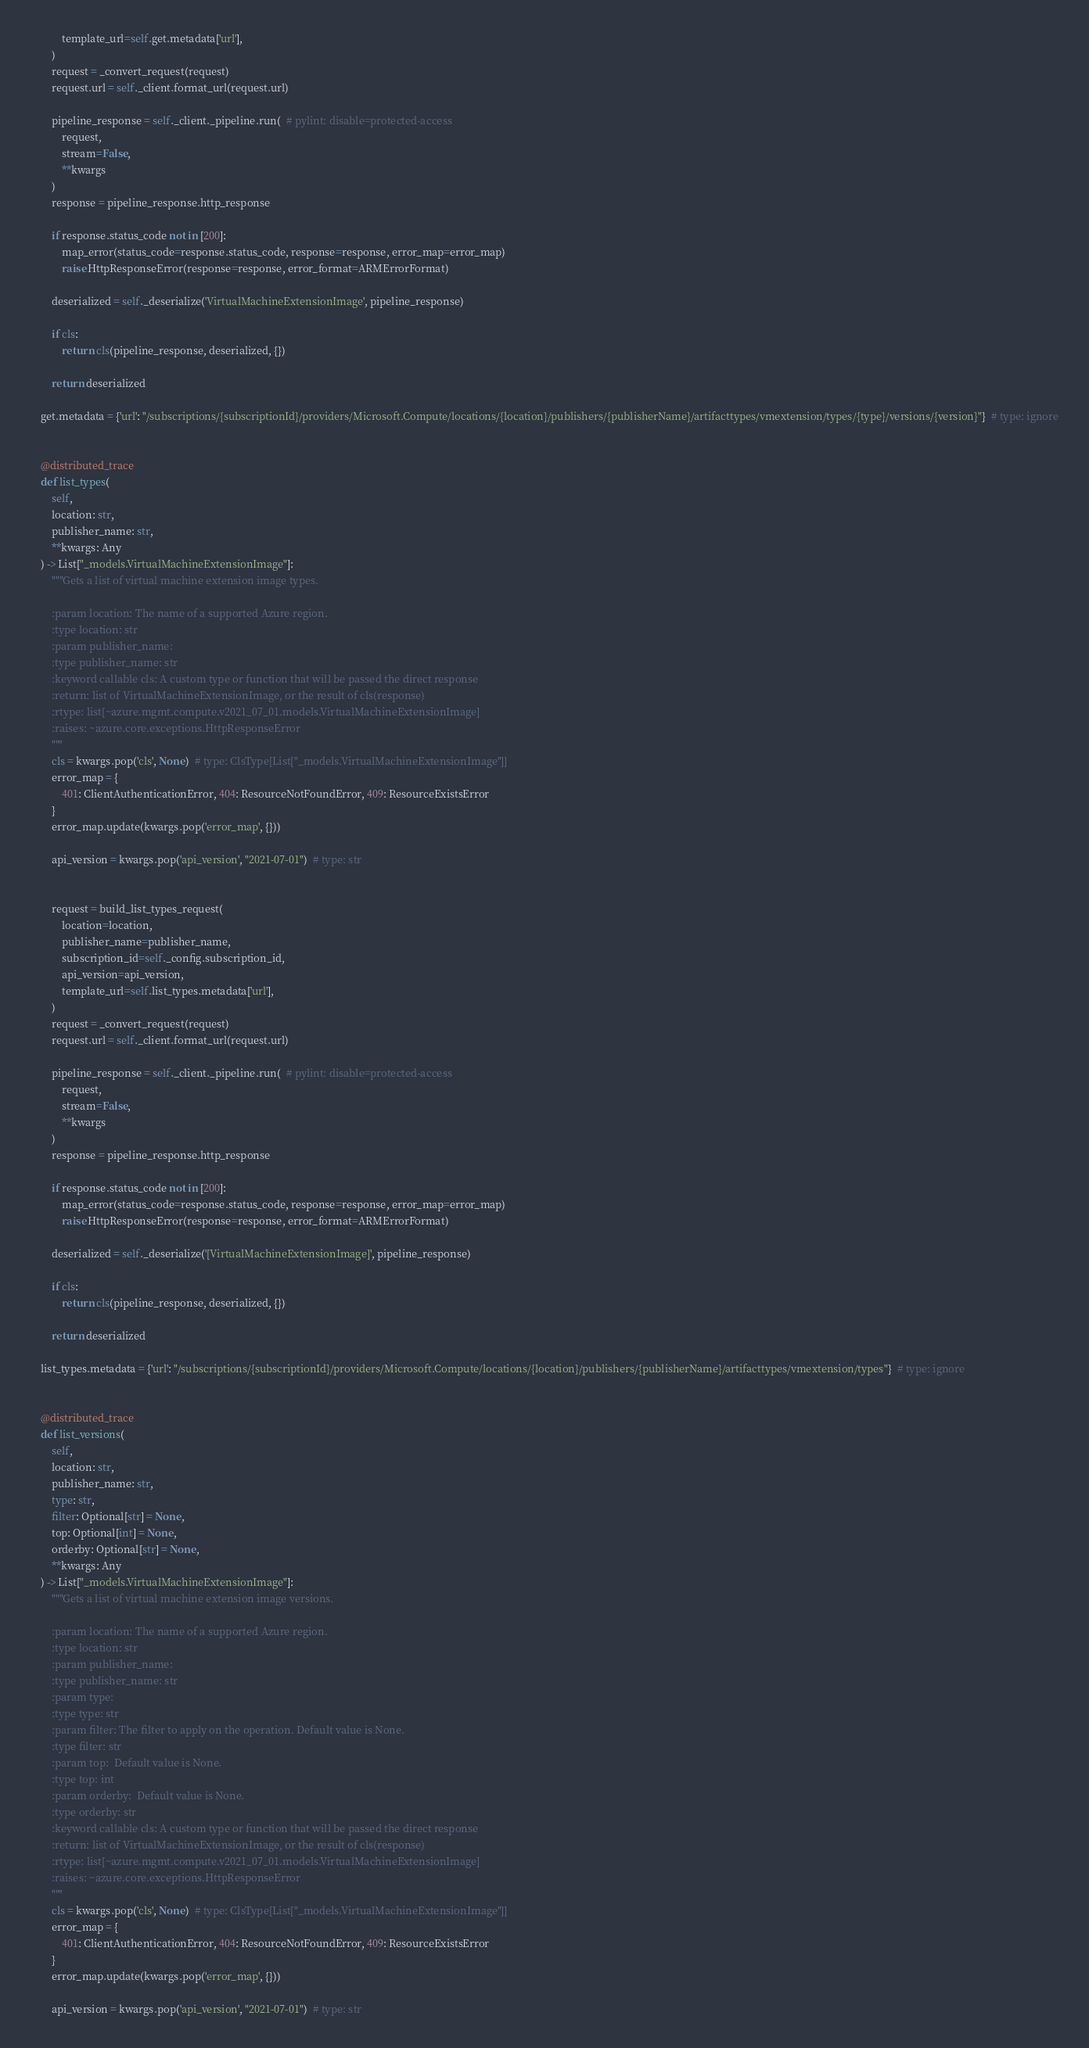<code> <loc_0><loc_0><loc_500><loc_500><_Python_>            template_url=self.get.metadata['url'],
        )
        request = _convert_request(request)
        request.url = self._client.format_url(request.url)

        pipeline_response = self._client._pipeline.run(  # pylint: disable=protected-access
            request,
            stream=False,
            **kwargs
        )
        response = pipeline_response.http_response

        if response.status_code not in [200]:
            map_error(status_code=response.status_code, response=response, error_map=error_map)
            raise HttpResponseError(response=response, error_format=ARMErrorFormat)

        deserialized = self._deserialize('VirtualMachineExtensionImage', pipeline_response)

        if cls:
            return cls(pipeline_response, deserialized, {})

        return deserialized

    get.metadata = {'url': "/subscriptions/{subscriptionId}/providers/Microsoft.Compute/locations/{location}/publishers/{publisherName}/artifacttypes/vmextension/types/{type}/versions/{version}"}  # type: ignore


    @distributed_trace
    def list_types(
        self,
        location: str,
        publisher_name: str,
        **kwargs: Any
    ) -> List["_models.VirtualMachineExtensionImage"]:
        """Gets a list of virtual machine extension image types.

        :param location: The name of a supported Azure region.
        :type location: str
        :param publisher_name:
        :type publisher_name: str
        :keyword callable cls: A custom type or function that will be passed the direct response
        :return: list of VirtualMachineExtensionImage, or the result of cls(response)
        :rtype: list[~azure.mgmt.compute.v2021_07_01.models.VirtualMachineExtensionImage]
        :raises: ~azure.core.exceptions.HttpResponseError
        """
        cls = kwargs.pop('cls', None)  # type: ClsType[List["_models.VirtualMachineExtensionImage"]]
        error_map = {
            401: ClientAuthenticationError, 404: ResourceNotFoundError, 409: ResourceExistsError
        }
        error_map.update(kwargs.pop('error_map', {}))

        api_version = kwargs.pop('api_version', "2021-07-01")  # type: str

        
        request = build_list_types_request(
            location=location,
            publisher_name=publisher_name,
            subscription_id=self._config.subscription_id,
            api_version=api_version,
            template_url=self.list_types.metadata['url'],
        )
        request = _convert_request(request)
        request.url = self._client.format_url(request.url)

        pipeline_response = self._client._pipeline.run(  # pylint: disable=protected-access
            request,
            stream=False,
            **kwargs
        )
        response = pipeline_response.http_response

        if response.status_code not in [200]:
            map_error(status_code=response.status_code, response=response, error_map=error_map)
            raise HttpResponseError(response=response, error_format=ARMErrorFormat)

        deserialized = self._deserialize('[VirtualMachineExtensionImage]', pipeline_response)

        if cls:
            return cls(pipeline_response, deserialized, {})

        return deserialized

    list_types.metadata = {'url': "/subscriptions/{subscriptionId}/providers/Microsoft.Compute/locations/{location}/publishers/{publisherName}/artifacttypes/vmextension/types"}  # type: ignore


    @distributed_trace
    def list_versions(
        self,
        location: str,
        publisher_name: str,
        type: str,
        filter: Optional[str] = None,
        top: Optional[int] = None,
        orderby: Optional[str] = None,
        **kwargs: Any
    ) -> List["_models.VirtualMachineExtensionImage"]:
        """Gets a list of virtual machine extension image versions.

        :param location: The name of a supported Azure region.
        :type location: str
        :param publisher_name:
        :type publisher_name: str
        :param type:
        :type type: str
        :param filter: The filter to apply on the operation. Default value is None.
        :type filter: str
        :param top:  Default value is None.
        :type top: int
        :param orderby:  Default value is None.
        :type orderby: str
        :keyword callable cls: A custom type or function that will be passed the direct response
        :return: list of VirtualMachineExtensionImage, or the result of cls(response)
        :rtype: list[~azure.mgmt.compute.v2021_07_01.models.VirtualMachineExtensionImage]
        :raises: ~azure.core.exceptions.HttpResponseError
        """
        cls = kwargs.pop('cls', None)  # type: ClsType[List["_models.VirtualMachineExtensionImage"]]
        error_map = {
            401: ClientAuthenticationError, 404: ResourceNotFoundError, 409: ResourceExistsError
        }
        error_map.update(kwargs.pop('error_map', {}))

        api_version = kwargs.pop('api_version', "2021-07-01")  # type: str
</code> 